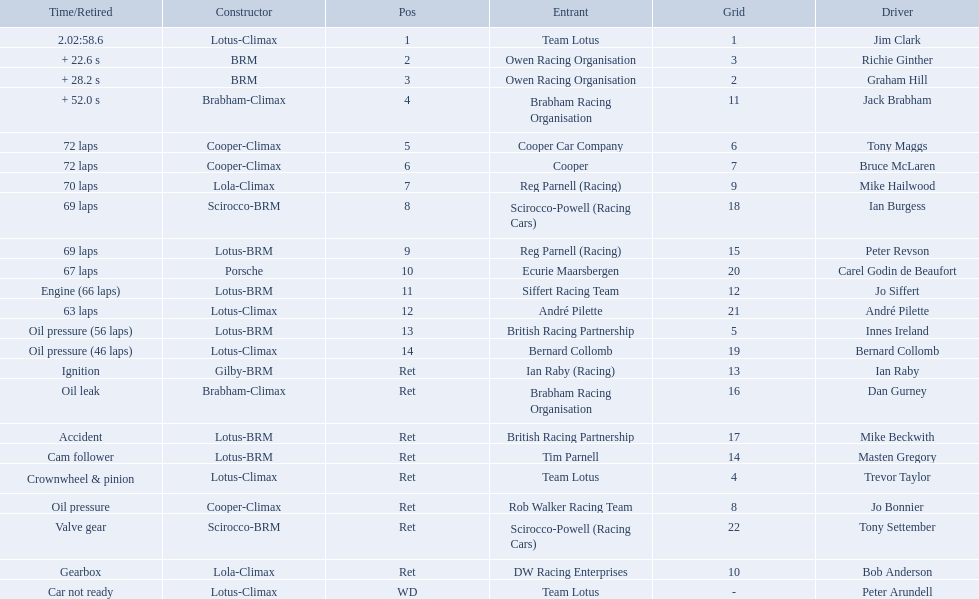Who are all the drivers? Jim Clark, Richie Ginther, Graham Hill, Jack Brabham, Tony Maggs, Bruce McLaren, Mike Hailwood, Ian Burgess, Peter Revson, Carel Godin de Beaufort, Jo Siffert, André Pilette, Innes Ireland, Bernard Collomb, Ian Raby, Dan Gurney, Mike Beckwith, Masten Gregory, Trevor Taylor, Jo Bonnier, Tony Settember, Bob Anderson, Peter Arundell. Which drove a cooper-climax? Tony Maggs, Bruce McLaren, Jo Bonnier. Of those, who was the top finisher? Tony Maggs. Who were the drivers at the 1963 international gold cup? Jim Clark, Richie Ginther, Graham Hill, Jack Brabham, Tony Maggs, Bruce McLaren, Mike Hailwood, Ian Burgess, Peter Revson, Carel Godin de Beaufort, Jo Siffert, André Pilette, Innes Ireland, Bernard Collomb, Ian Raby, Dan Gurney, Mike Beckwith, Masten Gregory, Trevor Taylor, Jo Bonnier, Tony Settember, Bob Anderson, Peter Arundell. What was tony maggs position? 5. What was jo siffert? 11. Who came in earlier? Tony Maggs. 